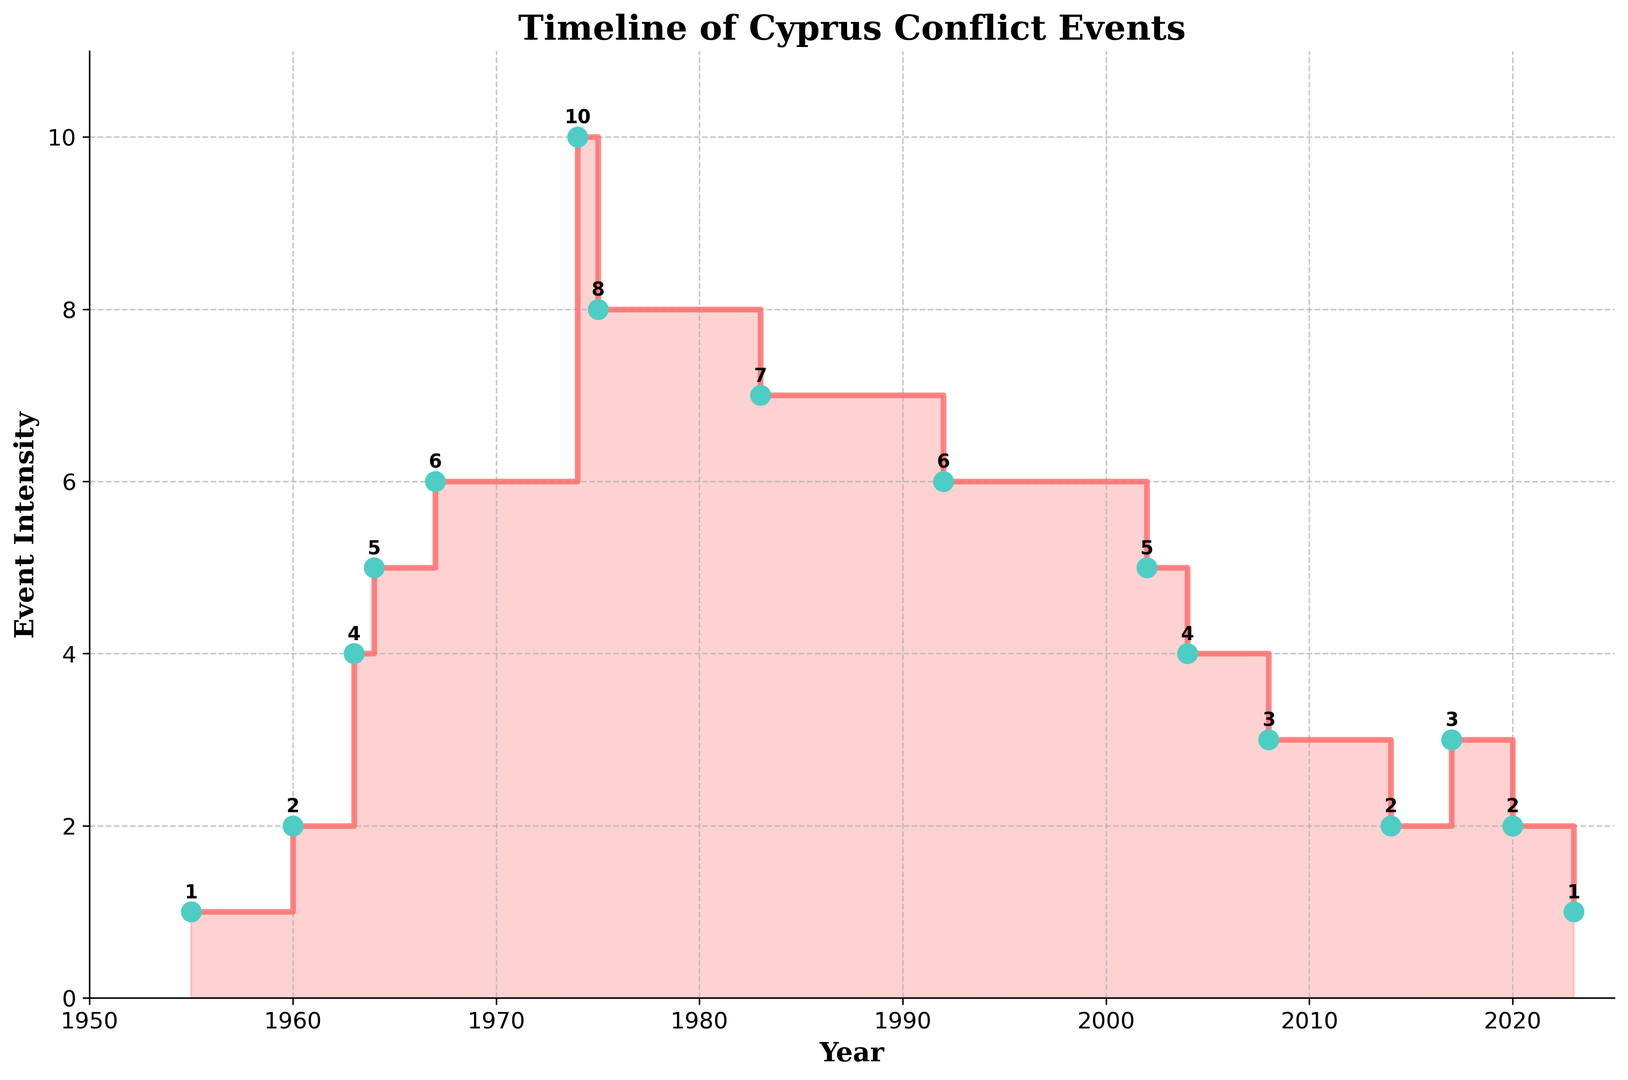What year experienced the highest event intensity? The highest point on the plot corresponds to an event intensity of 10, which occurred in 1974.
Answer: 1974 How did event intensity change from 1974 to 1975? In 1974, the event intensity was 10, and it decreased to 8 in 1975. The difference is 10 - 8 = 2.
Answer: Decreased by 2 What's the average event intensity in the decade of the 1970s (1970-1979)? During the 1970s, the event intensities were observed in the years 1974 (10) and 1975 (8). Average is (10 + 8) / 2 = 9.
Answer: 9 Which year had a higher event intensity: 2014 or 2017? By comparing the steps, 2014 had an intensity of 2, while 2017 had an intensity of 3. Therefore, 2017 had a higher intensity.
Answer: 2017 Did event intensity ever return to the level it was in 1963? In 1963, the event intensity was 4. According to the timeline, it returned to the level of 4 in 2004.
Answer: Yes Which decade saw the most significant drop in event intensity? From 1983 (7) to 1992 (6) and 2002 (5) to 2008 (3), the most significant drop was between 1975 (8) to 1983 (7), resulting in a drop of 4 units.
Answer: 1970s Which year marked a significant escalation in intensity compared to the previous year? The most significant escalation was from 1967 (6) to 1974 (10), marking an increase of 4 units.
Answer: 1974 Count the number of years where the event intensity was above 5. Years with intensity above 5 are 1967, 1974, 1975, and 1983.
Answer: 4 What period saw a continuous decrease in event intensity over multiple years? From 1974 (10) to 1975 (8), 1983 (7) to 1992 (6) to 2002 (5) to 2004 (4) to 2008 (3) to 2014 (2) indicates multiple decreases over several steps.
Answer: 1974 to 2008 Compare the event intensity in 1960 with that in 2023. In 1960, the intensity was 2. In 2023, it was also 1. Comparing these, 1960 was greater than 2023.
Answer: 1960 parents.appendChild_system 